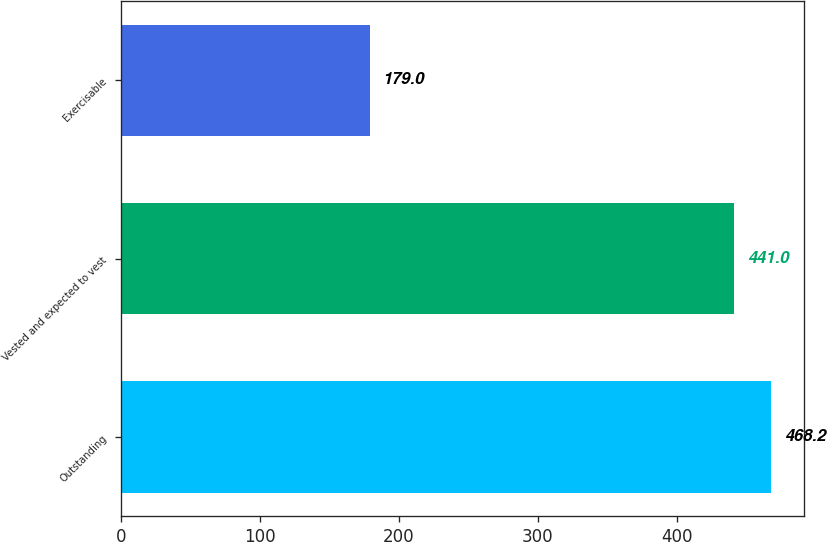<chart> <loc_0><loc_0><loc_500><loc_500><bar_chart><fcel>Outstanding<fcel>Vested and expected to vest<fcel>Exercisable<nl><fcel>468.2<fcel>441<fcel>179<nl></chart> 